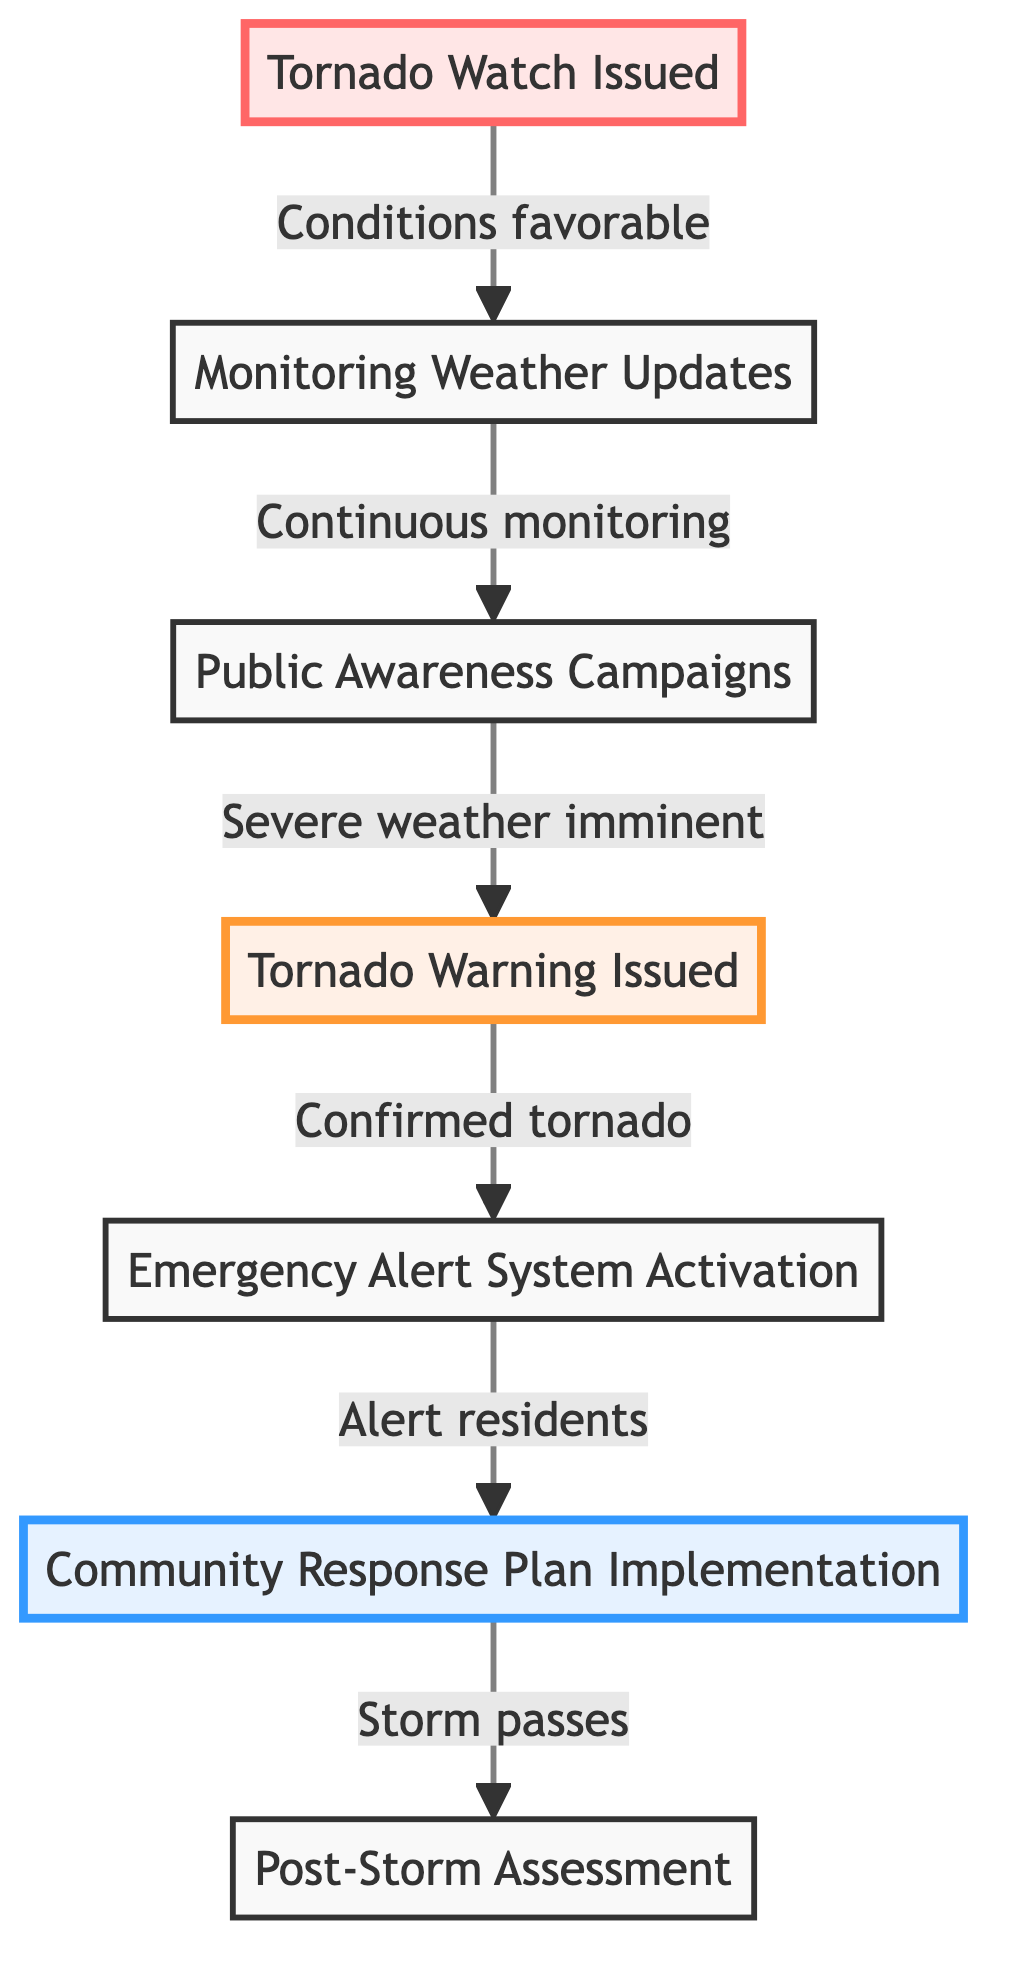What is the first step in the flow chart? The first step in the flow chart is "Tornado Watch Issued." This is indicated as the starting point of the process and is labeled clearly in the diagram.
Answer: Tornado Watch Issued How many steps are there from Tornado Watch to Post-Storm Assessment? By tracing the flow from "Tornado Watch Issued" to "Post-Storm Assessment," we identify a total of 6 steps which include Tornado Watch, Monitoring Weather Updates, Public Awareness Campaigns, Tornado Warning Issued, Emergency Alert System Activation, and Community Response Plan Implementation, leading to Post-Storm Assessment.
Answer: 6 What indicates a Tornado Warning? A "Tornado Warning" is indicated by the presence of a confirmed tornado sighted or strong radar indications of severe weather conditions impending. This is highlighted in the flow chart as a separate warning step.
Answer: A confirmed tornado What follows after the Emergency Alert System Activation? The flow chart shows that after the Emergency Alert System Activation (which alerts residents), the next step is "Community Response Plan Implementation." This is the planned response to the tornado threat.
Answer: Community Response Plan Implementation Which step includes informing the community? The step that involves informing the community is "Public Awareness Campaigns." This step is dedicated to alerting residents through different channels about the impending severe weather conditions.
Answer: Public Awareness Campaigns How does a Tornado Watch progress to a Tornado Warning? The progression goes from "Tornado Watch Issued," where conditions are favorable, to "Monitoring Weather Updates," where continuous updates are observed, leading to "Public Awareness Campaigns" that signal severe weather imminent, thereby resulting in a "Tornado Warning Issued." This shows a clear flow of steps that leads to the warning activation.
Answer: Monitoring Weather Updates, Public Awareness Campaigns What is the final step of the process depicted in the flow chart? The final step in the process is "Post-Storm Assessment," which occurs after the community response activities have been implemented and the storm has passed. This step is crucial for assessing damages and recovery.
Answer: Post-Storm Assessment What is the primary action taken during a Tornado Warning? The primary action during a Tornado Warning is the "Emergency Alert System Activation," which is designed to notify residents through radio and television, ensuring they are aware of the threat.
Answer: Emergency Alert System Activation 